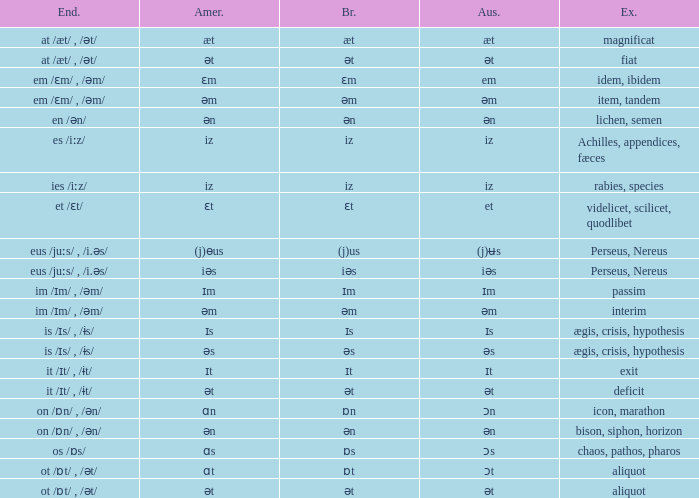Which Australian has British of ɒs? Ɔs. 